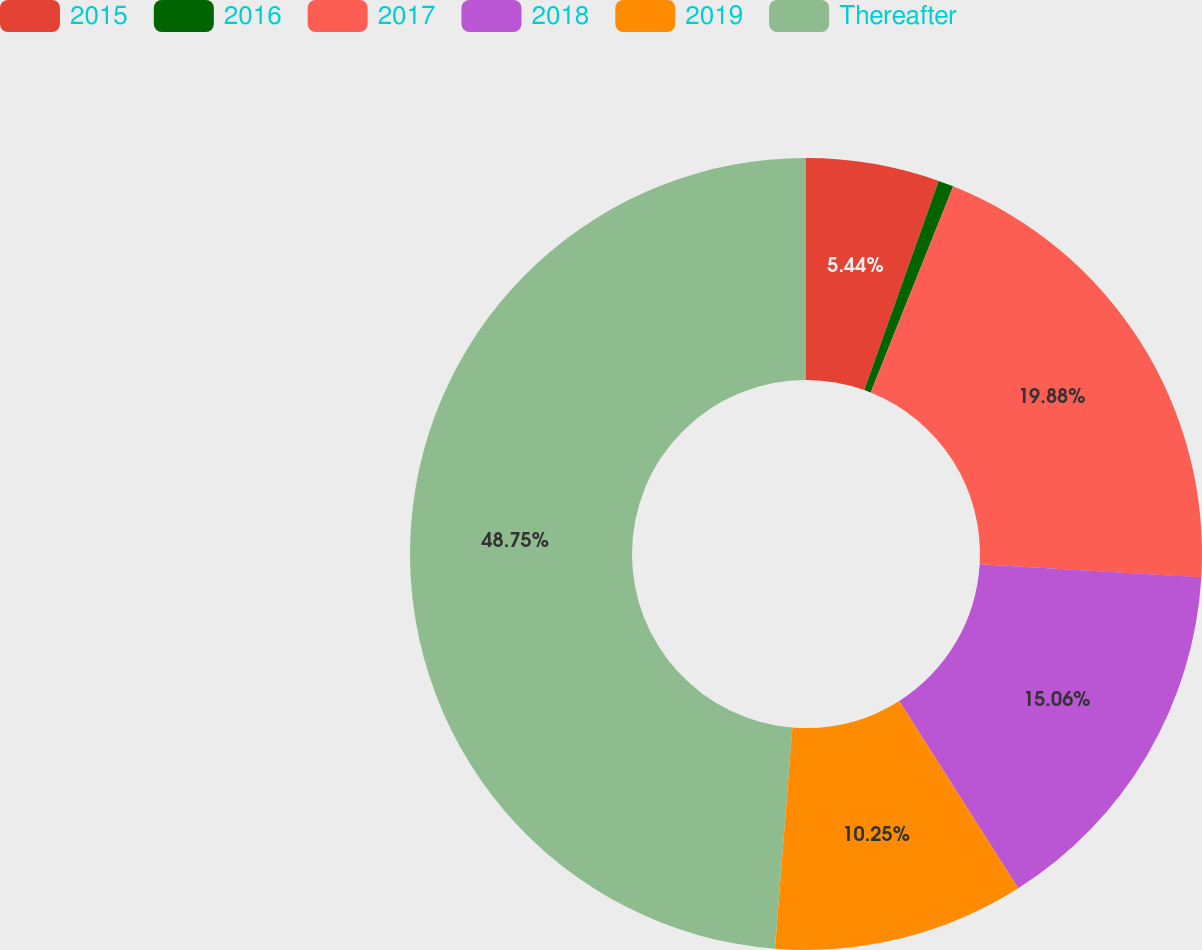<chart> <loc_0><loc_0><loc_500><loc_500><pie_chart><fcel>2015<fcel>2016<fcel>2017<fcel>2018<fcel>2019<fcel>Thereafter<nl><fcel>5.44%<fcel>0.62%<fcel>19.88%<fcel>15.06%<fcel>10.25%<fcel>48.75%<nl></chart> 